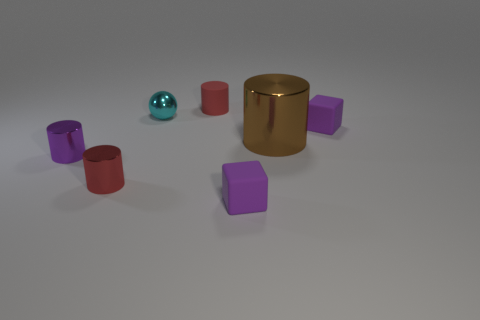Subtract all red cylinders. How many were subtracted if there are1red cylinders left? 1 Subtract 1 cylinders. How many cylinders are left? 3 Add 3 cyan metallic things. How many objects exist? 10 Subtract all cylinders. How many objects are left? 3 Subtract all brown cylinders. Subtract all small brown metal cylinders. How many objects are left? 6 Add 1 rubber blocks. How many rubber blocks are left? 3 Add 5 green matte blocks. How many green matte blocks exist? 5 Subtract 0 green cylinders. How many objects are left? 7 